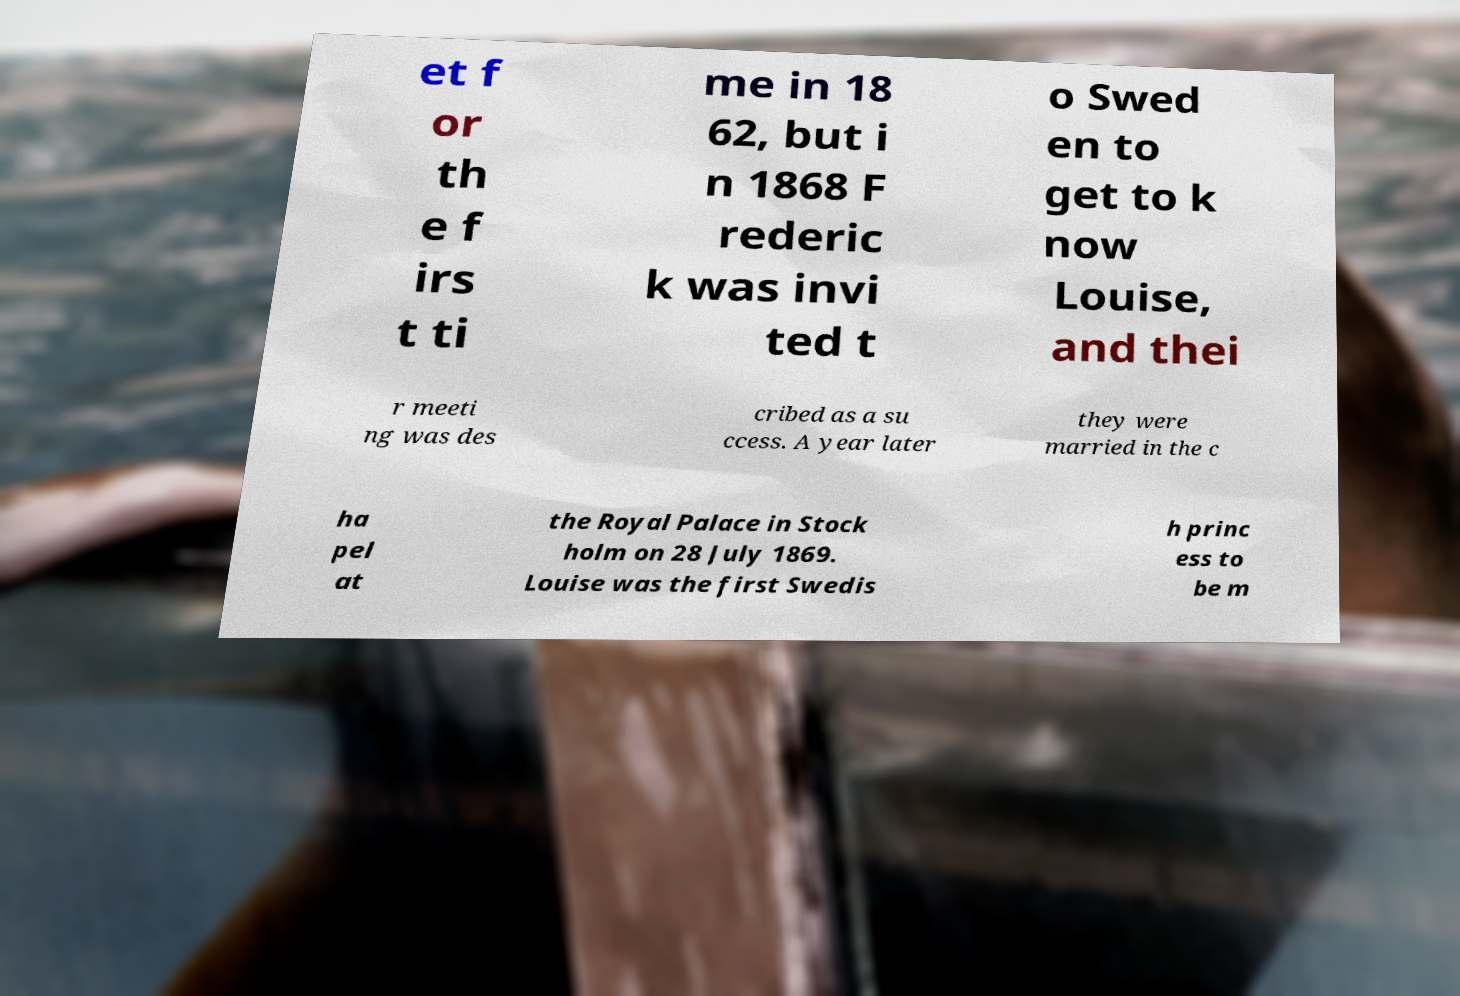Please identify and transcribe the text found in this image. et f or th e f irs t ti me in 18 62, but i n 1868 F rederic k was invi ted t o Swed en to get to k now Louise, and thei r meeti ng was des cribed as a su ccess. A year later they were married in the c ha pel at the Royal Palace in Stock holm on 28 July 1869. Louise was the first Swedis h princ ess to be m 